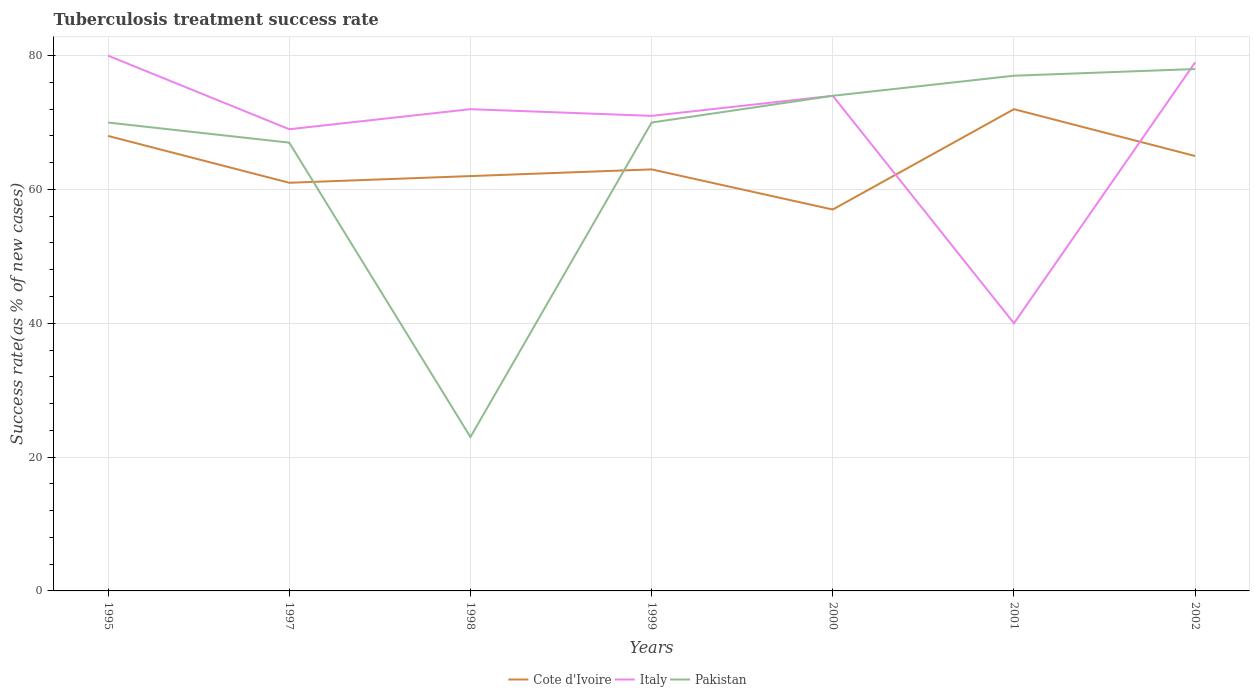How many different coloured lines are there?
Keep it short and to the point. 3. Is the number of lines equal to the number of legend labels?
Provide a short and direct response. Yes. Across all years, what is the maximum tuberculosis treatment success rate in Italy?
Offer a terse response. 40. In which year was the tuberculosis treatment success rate in Italy maximum?
Your answer should be compact. 2001. What is the total tuberculosis treatment success rate in Cote d'Ivoire in the graph?
Make the answer very short. -4. What is the difference between the highest and the second highest tuberculosis treatment success rate in Italy?
Your answer should be very brief. 40. How many years are there in the graph?
Offer a terse response. 7. Does the graph contain any zero values?
Your response must be concise. No. Does the graph contain grids?
Your response must be concise. Yes. Where does the legend appear in the graph?
Provide a short and direct response. Bottom center. How many legend labels are there?
Offer a terse response. 3. What is the title of the graph?
Your response must be concise. Tuberculosis treatment success rate. What is the label or title of the X-axis?
Provide a short and direct response. Years. What is the label or title of the Y-axis?
Provide a succinct answer. Success rate(as % of new cases). What is the Success rate(as % of new cases) in Cote d'Ivoire in 1995?
Your answer should be very brief. 68. What is the Success rate(as % of new cases) of Cote d'Ivoire in 1998?
Your answer should be very brief. 62. What is the Success rate(as % of new cases) in Pakistan in 1998?
Ensure brevity in your answer.  23. What is the Success rate(as % of new cases) of Cote d'Ivoire in 1999?
Provide a succinct answer. 63. What is the Success rate(as % of new cases) of Pakistan in 1999?
Offer a very short reply. 70. What is the Success rate(as % of new cases) in Cote d'Ivoire in 2000?
Ensure brevity in your answer.  57. What is the Success rate(as % of new cases) of Pakistan in 2001?
Offer a terse response. 77. What is the Success rate(as % of new cases) of Cote d'Ivoire in 2002?
Your response must be concise. 65. What is the Success rate(as % of new cases) in Italy in 2002?
Your answer should be compact. 79. Across all years, what is the maximum Success rate(as % of new cases) of Italy?
Your response must be concise. 80. What is the total Success rate(as % of new cases) of Cote d'Ivoire in the graph?
Provide a succinct answer. 448. What is the total Success rate(as % of new cases) of Italy in the graph?
Make the answer very short. 485. What is the total Success rate(as % of new cases) in Pakistan in the graph?
Offer a very short reply. 459. What is the difference between the Success rate(as % of new cases) in Cote d'Ivoire in 1995 and that in 1997?
Provide a short and direct response. 7. What is the difference between the Success rate(as % of new cases) in Italy in 1995 and that in 1997?
Your response must be concise. 11. What is the difference between the Success rate(as % of new cases) of Pakistan in 1995 and that in 1998?
Provide a succinct answer. 47. What is the difference between the Success rate(as % of new cases) of Italy in 1995 and that in 2000?
Keep it short and to the point. 6. What is the difference between the Success rate(as % of new cases) in Pakistan in 1995 and that in 2000?
Provide a short and direct response. -4. What is the difference between the Success rate(as % of new cases) of Pakistan in 1995 and that in 2001?
Ensure brevity in your answer.  -7. What is the difference between the Success rate(as % of new cases) in Pakistan in 1997 and that in 1998?
Offer a terse response. 44. What is the difference between the Success rate(as % of new cases) of Cote d'Ivoire in 1997 and that in 1999?
Your response must be concise. -2. What is the difference between the Success rate(as % of new cases) of Italy in 1997 and that in 1999?
Offer a very short reply. -2. What is the difference between the Success rate(as % of new cases) of Pakistan in 1997 and that in 1999?
Provide a short and direct response. -3. What is the difference between the Success rate(as % of new cases) in Italy in 1997 and that in 2000?
Keep it short and to the point. -5. What is the difference between the Success rate(as % of new cases) in Cote d'Ivoire in 1997 and that in 2001?
Make the answer very short. -11. What is the difference between the Success rate(as % of new cases) in Italy in 1997 and that in 2001?
Give a very brief answer. 29. What is the difference between the Success rate(as % of new cases) in Pakistan in 1997 and that in 2001?
Make the answer very short. -10. What is the difference between the Success rate(as % of new cases) of Cote d'Ivoire in 1997 and that in 2002?
Your answer should be very brief. -4. What is the difference between the Success rate(as % of new cases) of Italy in 1997 and that in 2002?
Provide a short and direct response. -10. What is the difference between the Success rate(as % of new cases) of Cote d'Ivoire in 1998 and that in 1999?
Keep it short and to the point. -1. What is the difference between the Success rate(as % of new cases) of Italy in 1998 and that in 1999?
Offer a terse response. 1. What is the difference between the Success rate(as % of new cases) in Pakistan in 1998 and that in 1999?
Ensure brevity in your answer.  -47. What is the difference between the Success rate(as % of new cases) in Italy in 1998 and that in 2000?
Your answer should be very brief. -2. What is the difference between the Success rate(as % of new cases) of Pakistan in 1998 and that in 2000?
Your answer should be compact. -51. What is the difference between the Success rate(as % of new cases) in Italy in 1998 and that in 2001?
Your answer should be compact. 32. What is the difference between the Success rate(as % of new cases) of Pakistan in 1998 and that in 2001?
Your response must be concise. -54. What is the difference between the Success rate(as % of new cases) in Cote d'Ivoire in 1998 and that in 2002?
Your answer should be compact. -3. What is the difference between the Success rate(as % of new cases) in Pakistan in 1998 and that in 2002?
Provide a succinct answer. -55. What is the difference between the Success rate(as % of new cases) of Italy in 1999 and that in 2000?
Keep it short and to the point. -3. What is the difference between the Success rate(as % of new cases) in Pakistan in 1999 and that in 2000?
Offer a terse response. -4. What is the difference between the Success rate(as % of new cases) in Cote d'Ivoire in 1999 and that in 2001?
Your response must be concise. -9. What is the difference between the Success rate(as % of new cases) of Italy in 1999 and that in 2001?
Your response must be concise. 31. What is the difference between the Success rate(as % of new cases) in Pakistan in 1999 and that in 2001?
Keep it short and to the point. -7. What is the difference between the Success rate(as % of new cases) in Pakistan in 1999 and that in 2002?
Offer a terse response. -8. What is the difference between the Success rate(as % of new cases) in Cote d'Ivoire in 2000 and that in 2001?
Your answer should be very brief. -15. What is the difference between the Success rate(as % of new cases) of Pakistan in 2000 and that in 2002?
Your answer should be compact. -4. What is the difference between the Success rate(as % of new cases) in Italy in 2001 and that in 2002?
Keep it short and to the point. -39. What is the difference between the Success rate(as % of new cases) in Cote d'Ivoire in 1995 and the Success rate(as % of new cases) in Italy in 1998?
Keep it short and to the point. -4. What is the difference between the Success rate(as % of new cases) in Cote d'Ivoire in 1995 and the Success rate(as % of new cases) in Pakistan in 1998?
Offer a terse response. 45. What is the difference between the Success rate(as % of new cases) of Italy in 1995 and the Success rate(as % of new cases) of Pakistan in 1998?
Your answer should be very brief. 57. What is the difference between the Success rate(as % of new cases) in Cote d'Ivoire in 1995 and the Success rate(as % of new cases) in Pakistan in 1999?
Provide a short and direct response. -2. What is the difference between the Success rate(as % of new cases) in Cote d'Ivoire in 1995 and the Success rate(as % of new cases) in Italy in 2000?
Keep it short and to the point. -6. What is the difference between the Success rate(as % of new cases) of Cote d'Ivoire in 1995 and the Success rate(as % of new cases) of Pakistan in 2000?
Your response must be concise. -6. What is the difference between the Success rate(as % of new cases) of Cote d'Ivoire in 1995 and the Success rate(as % of new cases) of Italy in 2001?
Give a very brief answer. 28. What is the difference between the Success rate(as % of new cases) in Cote d'Ivoire in 1995 and the Success rate(as % of new cases) in Pakistan in 2001?
Your response must be concise. -9. What is the difference between the Success rate(as % of new cases) in Italy in 1995 and the Success rate(as % of new cases) in Pakistan in 2002?
Offer a terse response. 2. What is the difference between the Success rate(as % of new cases) of Cote d'Ivoire in 1997 and the Success rate(as % of new cases) of Italy in 1998?
Give a very brief answer. -11. What is the difference between the Success rate(as % of new cases) in Cote d'Ivoire in 1997 and the Success rate(as % of new cases) in Pakistan in 1998?
Keep it short and to the point. 38. What is the difference between the Success rate(as % of new cases) of Cote d'Ivoire in 1997 and the Success rate(as % of new cases) of Italy in 1999?
Offer a terse response. -10. What is the difference between the Success rate(as % of new cases) in Italy in 1997 and the Success rate(as % of new cases) in Pakistan in 1999?
Provide a succinct answer. -1. What is the difference between the Success rate(as % of new cases) in Cote d'Ivoire in 1997 and the Success rate(as % of new cases) in Italy in 2000?
Provide a short and direct response. -13. What is the difference between the Success rate(as % of new cases) of Cote d'Ivoire in 1997 and the Success rate(as % of new cases) of Pakistan in 2001?
Provide a succinct answer. -16. What is the difference between the Success rate(as % of new cases) in Cote d'Ivoire in 1997 and the Success rate(as % of new cases) in Italy in 2002?
Your answer should be compact. -18. What is the difference between the Success rate(as % of new cases) in Italy in 1997 and the Success rate(as % of new cases) in Pakistan in 2002?
Offer a terse response. -9. What is the difference between the Success rate(as % of new cases) in Cote d'Ivoire in 1998 and the Success rate(as % of new cases) in Italy in 2000?
Give a very brief answer. -12. What is the difference between the Success rate(as % of new cases) of Italy in 1998 and the Success rate(as % of new cases) of Pakistan in 2000?
Give a very brief answer. -2. What is the difference between the Success rate(as % of new cases) of Cote d'Ivoire in 1998 and the Success rate(as % of new cases) of Italy in 2001?
Your answer should be compact. 22. What is the difference between the Success rate(as % of new cases) in Cote d'Ivoire in 1998 and the Success rate(as % of new cases) in Pakistan in 2001?
Make the answer very short. -15. What is the difference between the Success rate(as % of new cases) in Cote d'Ivoire in 1998 and the Success rate(as % of new cases) in Italy in 2002?
Provide a short and direct response. -17. What is the difference between the Success rate(as % of new cases) of Cote d'Ivoire in 1999 and the Success rate(as % of new cases) of Pakistan in 2000?
Give a very brief answer. -11. What is the difference between the Success rate(as % of new cases) of Italy in 1999 and the Success rate(as % of new cases) of Pakistan in 2000?
Provide a short and direct response. -3. What is the difference between the Success rate(as % of new cases) of Cote d'Ivoire in 1999 and the Success rate(as % of new cases) of Pakistan in 2001?
Give a very brief answer. -14. What is the difference between the Success rate(as % of new cases) of Italy in 1999 and the Success rate(as % of new cases) of Pakistan in 2001?
Keep it short and to the point. -6. What is the difference between the Success rate(as % of new cases) in Cote d'Ivoire in 1999 and the Success rate(as % of new cases) in Italy in 2002?
Offer a terse response. -16. What is the difference between the Success rate(as % of new cases) of Cote d'Ivoire in 1999 and the Success rate(as % of new cases) of Pakistan in 2002?
Keep it short and to the point. -15. What is the difference between the Success rate(as % of new cases) of Italy in 1999 and the Success rate(as % of new cases) of Pakistan in 2002?
Ensure brevity in your answer.  -7. What is the difference between the Success rate(as % of new cases) in Cote d'Ivoire in 2000 and the Success rate(as % of new cases) in Italy in 2001?
Offer a very short reply. 17. What is the difference between the Success rate(as % of new cases) of Cote d'Ivoire in 2000 and the Success rate(as % of new cases) of Pakistan in 2001?
Your response must be concise. -20. What is the difference between the Success rate(as % of new cases) of Italy in 2000 and the Success rate(as % of new cases) of Pakistan in 2001?
Provide a succinct answer. -3. What is the difference between the Success rate(as % of new cases) of Cote d'Ivoire in 2000 and the Success rate(as % of new cases) of Italy in 2002?
Keep it short and to the point. -22. What is the difference between the Success rate(as % of new cases) of Italy in 2000 and the Success rate(as % of new cases) of Pakistan in 2002?
Provide a short and direct response. -4. What is the difference between the Success rate(as % of new cases) in Cote d'Ivoire in 2001 and the Success rate(as % of new cases) in Italy in 2002?
Offer a very short reply. -7. What is the difference between the Success rate(as % of new cases) of Italy in 2001 and the Success rate(as % of new cases) of Pakistan in 2002?
Your answer should be compact. -38. What is the average Success rate(as % of new cases) in Italy per year?
Give a very brief answer. 69.29. What is the average Success rate(as % of new cases) of Pakistan per year?
Make the answer very short. 65.57. In the year 1995, what is the difference between the Success rate(as % of new cases) of Cote d'Ivoire and Success rate(as % of new cases) of Italy?
Provide a short and direct response. -12. In the year 1998, what is the difference between the Success rate(as % of new cases) of Cote d'Ivoire and Success rate(as % of new cases) of Italy?
Your answer should be compact. -10. In the year 1998, what is the difference between the Success rate(as % of new cases) in Cote d'Ivoire and Success rate(as % of new cases) in Pakistan?
Ensure brevity in your answer.  39. In the year 1999, what is the difference between the Success rate(as % of new cases) of Italy and Success rate(as % of new cases) of Pakistan?
Ensure brevity in your answer.  1. In the year 2000, what is the difference between the Success rate(as % of new cases) in Cote d'Ivoire and Success rate(as % of new cases) in Italy?
Your response must be concise. -17. In the year 2001, what is the difference between the Success rate(as % of new cases) in Italy and Success rate(as % of new cases) in Pakistan?
Your answer should be very brief. -37. In the year 2002, what is the difference between the Success rate(as % of new cases) of Cote d'Ivoire and Success rate(as % of new cases) of Italy?
Your answer should be compact. -14. In the year 2002, what is the difference between the Success rate(as % of new cases) in Cote d'Ivoire and Success rate(as % of new cases) in Pakistan?
Make the answer very short. -13. What is the ratio of the Success rate(as % of new cases) in Cote d'Ivoire in 1995 to that in 1997?
Offer a terse response. 1.11. What is the ratio of the Success rate(as % of new cases) of Italy in 1995 to that in 1997?
Keep it short and to the point. 1.16. What is the ratio of the Success rate(as % of new cases) of Pakistan in 1995 to that in 1997?
Offer a very short reply. 1.04. What is the ratio of the Success rate(as % of new cases) in Cote d'Ivoire in 1995 to that in 1998?
Ensure brevity in your answer.  1.1. What is the ratio of the Success rate(as % of new cases) of Italy in 1995 to that in 1998?
Your response must be concise. 1.11. What is the ratio of the Success rate(as % of new cases) of Pakistan in 1995 to that in 1998?
Keep it short and to the point. 3.04. What is the ratio of the Success rate(as % of new cases) in Cote d'Ivoire in 1995 to that in 1999?
Your response must be concise. 1.08. What is the ratio of the Success rate(as % of new cases) in Italy in 1995 to that in 1999?
Ensure brevity in your answer.  1.13. What is the ratio of the Success rate(as % of new cases) in Pakistan in 1995 to that in 1999?
Ensure brevity in your answer.  1. What is the ratio of the Success rate(as % of new cases) of Cote d'Ivoire in 1995 to that in 2000?
Offer a terse response. 1.19. What is the ratio of the Success rate(as % of new cases) of Italy in 1995 to that in 2000?
Your answer should be very brief. 1.08. What is the ratio of the Success rate(as % of new cases) in Pakistan in 1995 to that in 2000?
Provide a succinct answer. 0.95. What is the ratio of the Success rate(as % of new cases) of Cote d'Ivoire in 1995 to that in 2001?
Offer a terse response. 0.94. What is the ratio of the Success rate(as % of new cases) in Pakistan in 1995 to that in 2001?
Make the answer very short. 0.91. What is the ratio of the Success rate(as % of new cases) of Cote d'Ivoire in 1995 to that in 2002?
Your response must be concise. 1.05. What is the ratio of the Success rate(as % of new cases) of Italy in 1995 to that in 2002?
Offer a very short reply. 1.01. What is the ratio of the Success rate(as % of new cases) of Pakistan in 1995 to that in 2002?
Make the answer very short. 0.9. What is the ratio of the Success rate(as % of new cases) in Cote d'Ivoire in 1997 to that in 1998?
Make the answer very short. 0.98. What is the ratio of the Success rate(as % of new cases) in Italy in 1997 to that in 1998?
Give a very brief answer. 0.96. What is the ratio of the Success rate(as % of new cases) in Pakistan in 1997 to that in 1998?
Make the answer very short. 2.91. What is the ratio of the Success rate(as % of new cases) in Cote d'Ivoire in 1997 to that in 1999?
Your response must be concise. 0.97. What is the ratio of the Success rate(as % of new cases) of Italy in 1997 to that in 1999?
Your answer should be compact. 0.97. What is the ratio of the Success rate(as % of new cases) of Pakistan in 1997 to that in 1999?
Your answer should be compact. 0.96. What is the ratio of the Success rate(as % of new cases) in Cote d'Ivoire in 1997 to that in 2000?
Ensure brevity in your answer.  1.07. What is the ratio of the Success rate(as % of new cases) of Italy in 1997 to that in 2000?
Make the answer very short. 0.93. What is the ratio of the Success rate(as % of new cases) in Pakistan in 1997 to that in 2000?
Your answer should be compact. 0.91. What is the ratio of the Success rate(as % of new cases) of Cote d'Ivoire in 1997 to that in 2001?
Keep it short and to the point. 0.85. What is the ratio of the Success rate(as % of new cases) of Italy in 1997 to that in 2001?
Give a very brief answer. 1.73. What is the ratio of the Success rate(as % of new cases) in Pakistan in 1997 to that in 2001?
Make the answer very short. 0.87. What is the ratio of the Success rate(as % of new cases) of Cote d'Ivoire in 1997 to that in 2002?
Give a very brief answer. 0.94. What is the ratio of the Success rate(as % of new cases) in Italy in 1997 to that in 2002?
Give a very brief answer. 0.87. What is the ratio of the Success rate(as % of new cases) in Pakistan in 1997 to that in 2002?
Provide a succinct answer. 0.86. What is the ratio of the Success rate(as % of new cases) in Cote d'Ivoire in 1998 to that in 1999?
Make the answer very short. 0.98. What is the ratio of the Success rate(as % of new cases) in Italy in 1998 to that in 1999?
Your response must be concise. 1.01. What is the ratio of the Success rate(as % of new cases) of Pakistan in 1998 to that in 1999?
Your answer should be very brief. 0.33. What is the ratio of the Success rate(as % of new cases) in Cote d'Ivoire in 1998 to that in 2000?
Your answer should be very brief. 1.09. What is the ratio of the Success rate(as % of new cases) of Pakistan in 1998 to that in 2000?
Provide a short and direct response. 0.31. What is the ratio of the Success rate(as % of new cases) of Cote d'Ivoire in 1998 to that in 2001?
Make the answer very short. 0.86. What is the ratio of the Success rate(as % of new cases) in Pakistan in 1998 to that in 2001?
Make the answer very short. 0.3. What is the ratio of the Success rate(as % of new cases) of Cote d'Ivoire in 1998 to that in 2002?
Make the answer very short. 0.95. What is the ratio of the Success rate(as % of new cases) in Italy in 1998 to that in 2002?
Provide a short and direct response. 0.91. What is the ratio of the Success rate(as % of new cases) in Pakistan in 1998 to that in 2002?
Make the answer very short. 0.29. What is the ratio of the Success rate(as % of new cases) of Cote d'Ivoire in 1999 to that in 2000?
Offer a terse response. 1.11. What is the ratio of the Success rate(as % of new cases) in Italy in 1999 to that in 2000?
Your response must be concise. 0.96. What is the ratio of the Success rate(as % of new cases) in Pakistan in 1999 to that in 2000?
Provide a short and direct response. 0.95. What is the ratio of the Success rate(as % of new cases) of Cote d'Ivoire in 1999 to that in 2001?
Your answer should be compact. 0.88. What is the ratio of the Success rate(as % of new cases) in Italy in 1999 to that in 2001?
Ensure brevity in your answer.  1.77. What is the ratio of the Success rate(as % of new cases) in Pakistan in 1999 to that in 2001?
Provide a succinct answer. 0.91. What is the ratio of the Success rate(as % of new cases) of Cote d'Ivoire in 1999 to that in 2002?
Provide a succinct answer. 0.97. What is the ratio of the Success rate(as % of new cases) of Italy in 1999 to that in 2002?
Give a very brief answer. 0.9. What is the ratio of the Success rate(as % of new cases) of Pakistan in 1999 to that in 2002?
Make the answer very short. 0.9. What is the ratio of the Success rate(as % of new cases) in Cote d'Ivoire in 2000 to that in 2001?
Your answer should be compact. 0.79. What is the ratio of the Success rate(as % of new cases) in Italy in 2000 to that in 2001?
Your answer should be very brief. 1.85. What is the ratio of the Success rate(as % of new cases) of Cote d'Ivoire in 2000 to that in 2002?
Keep it short and to the point. 0.88. What is the ratio of the Success rate(as % of new cases) of Italy in 2000 to that in 2002?
Provide a succinct answer. 0.94. What is the ratio of the Success rate(as % of new cases) in Pakistan in 2000 to that in 2002?
Ensure brevity in your answer.  0.95. What is the ratio of the Success rate(as % of new cases) in Cote d'Ivoire in 2001 to that in 2002?
Offer a terse response. 1.11. What is the ratio of the Success rate(as % of new cases) in Italy in 2001 to that in 2002?
Provide a short and direct response. 0.51. What is the ratio of the Success rate(as % of new cases) of Pakistan in 2001 to that in 2002?
Your answer should be compact. 0.99. What is the difference between the highest and the second highest Success rate(as % of new cases) in Cote d'Ivoire?
Keep it short and to the point. 4. What is the difference between the highest and the second highest Success rate(as % of new cases) of Italy?
Ensure brevity in your answer.  1. What is the difference between the highest and the second highest Success rate(as % of new cases) in Pakistan?
Your response must be concise. 1. What is the difference between the highest and the lowest Success rate(as % of new cases) of Cote d'Ivoire?
Your response must be concise. 15. What is the difference between the highest and the lowest Success rate(as % of new cases) of Italy?
Your answer should be very brief. 40. 